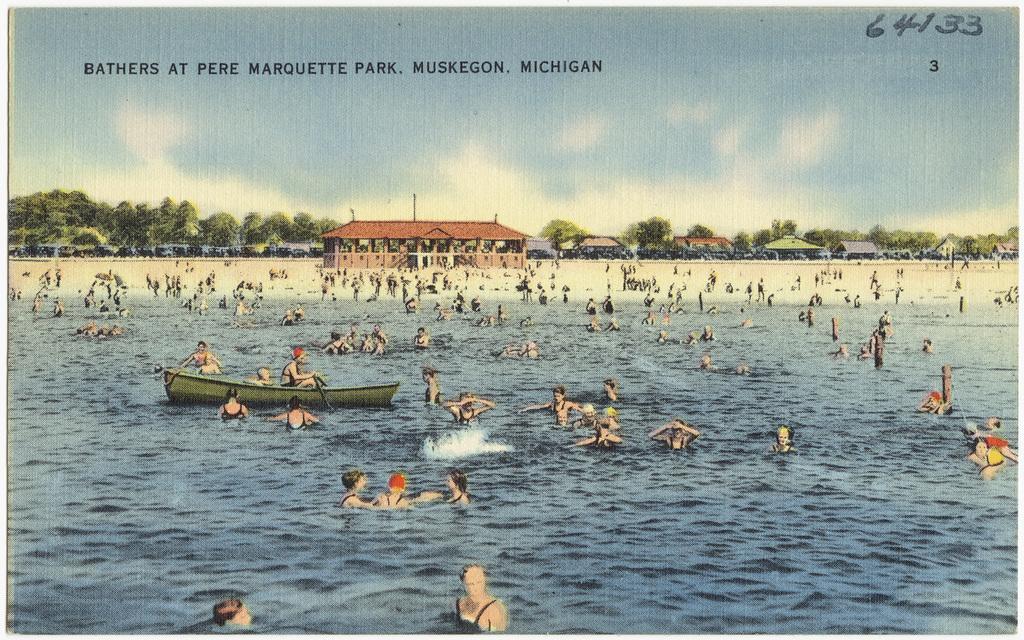Could you give a brief overview of what you see in this image? In this image we can see depictions of person, buildings, trees, water. At the top of the image there is text. 